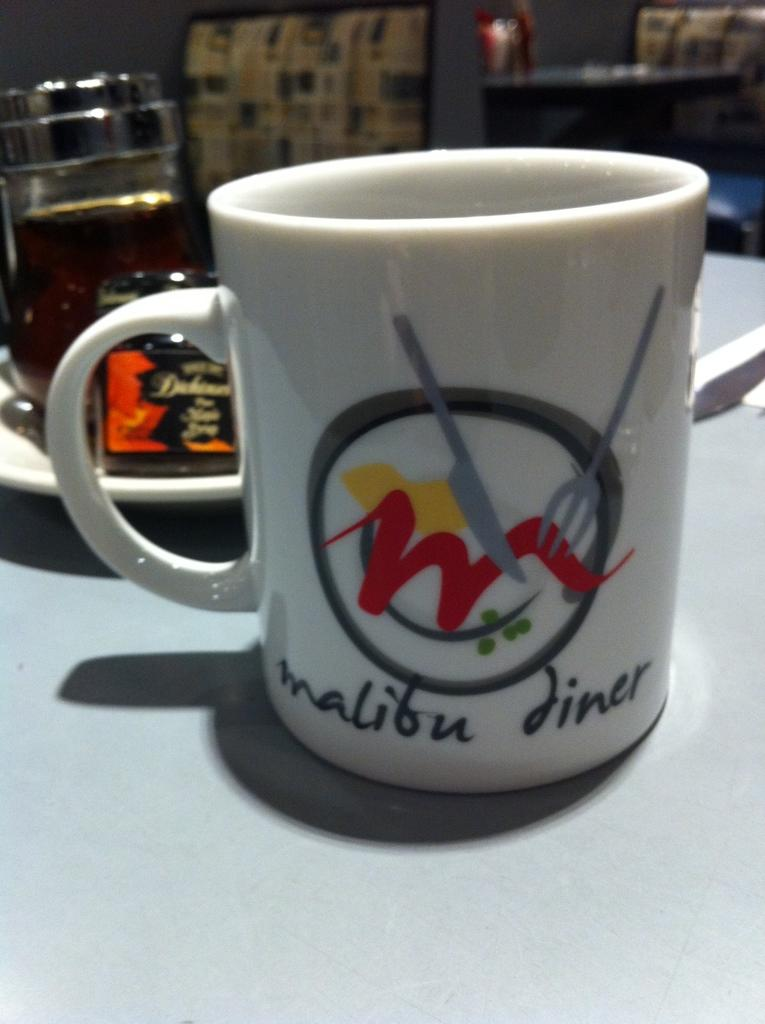<image>
Create a compact narrative representing the image presented. A white mug with the name Malibu Diner printed on it. 